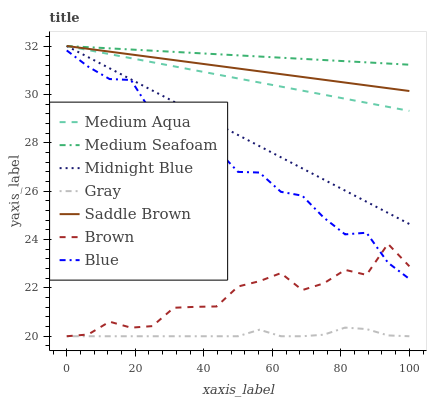Does Gray have the minimum area under the curve?
Answer yes or no. Yes. Does Medium Seafoam have the maximum area under the curve?
Answer yes or no. Yes. Does Midnight Blue have the minimum area under the curve?
Answer yes or no. No. Does Midnight Blue have the maximum area under the curve?
Answer yes or no. No. Is Medium Aqua the smoothest?
Answer yes or no. Yes. Is Brown the roughest?
Answer yes or no. Yes. Is Gray the smoothest?
Answer yes or no. No. Is Gray the roughest?
Answer yes or no. No. Does Gray have the lowest value?
Answer yes or no. Yes. Does Midnight Blue have the lowest value?
Answer yes or no. No. Does Saddle Brown have the highest value?
Answer yes or no. Yes. Does Gray have the highest value?
Answer yes or no. No. Is Gray less than Medium Seafoam?
Answer yes or no. Yes. Is Midnight Blue greater than Brown?
Answer yes or no. Yes. Does Medium Aqua intersect Saddle Brown?
Answer yes or no. Yes. Is Medium Aqua less than Saddle Brown?
Answer yes or no. No. Is Medium Aqua greater than Saddle Brown?
Answer yes or no. No. Does Gray intersect Medium Seafoam?
Answer yes or no. No. 